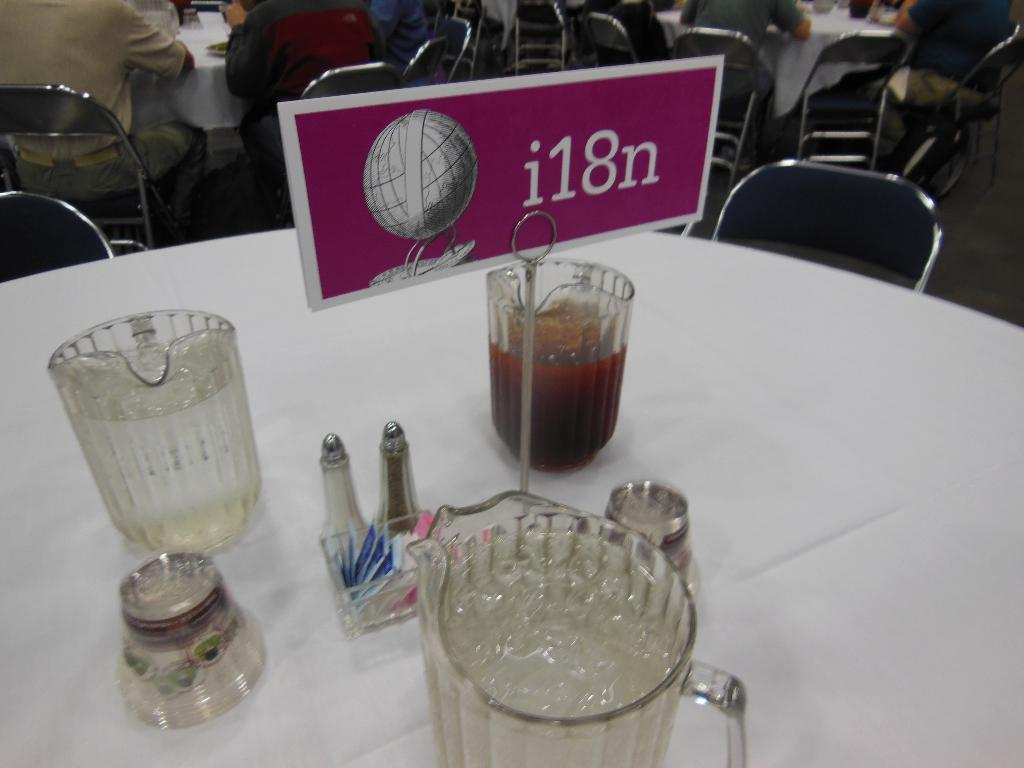<image>
Provide a brief description of the given image. A table set up for a conference with a I18n sign in the center. 